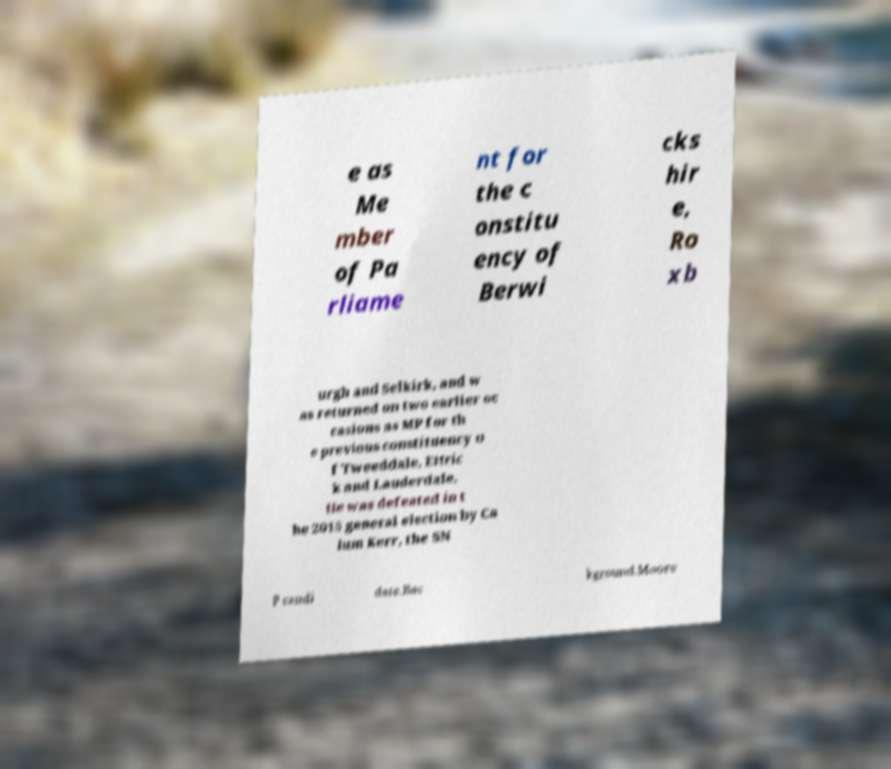I need the written content from this picture converted into text. Can you do that? e as Me mber of Pa rliame nt for the c onstitu ency of Berwi cks hir e, Ro xb urgh and Selkirk, and w as returned on two earlier oc casions as MP for th e previous constituency o f Tweeddale, Ettric k and Lauderdale. He was defeated in t he 2015 general election by Ca lum Kerr, the SN P candi date.Bac kground.Moore 